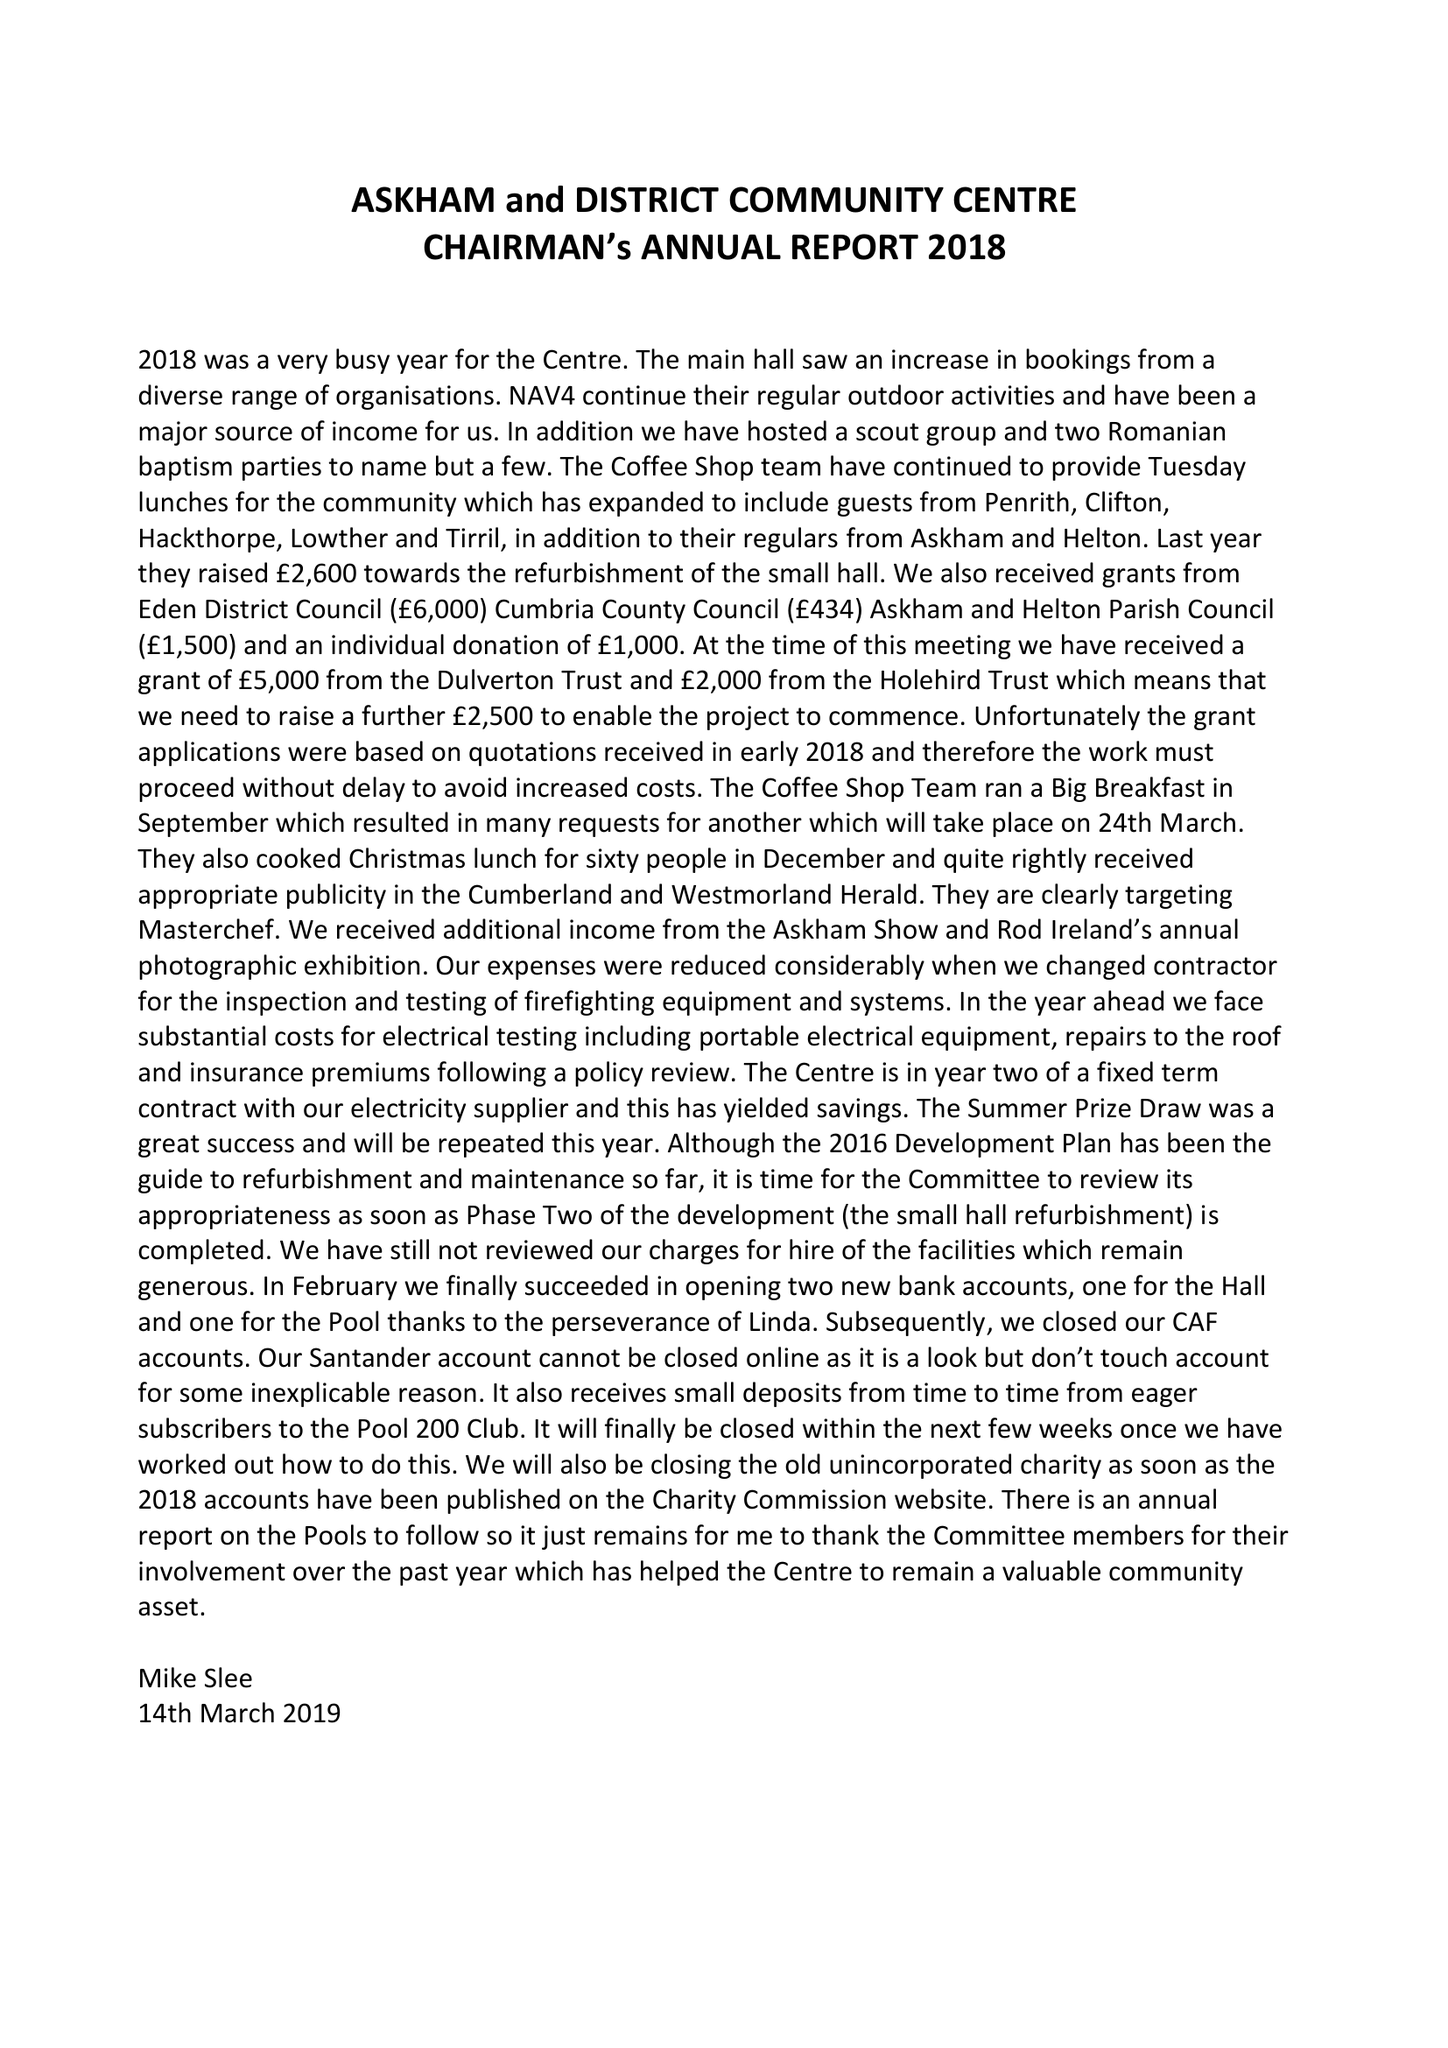What is the value for the income_annually_in_british_pounds?
Answer the question using a single word or phrase. 57602.00 